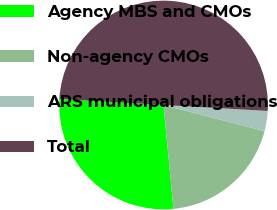Convert chart. <chart><loc_0><loc_0><loc_500><loc_500><pie_chart><fcel>Agency MBS and CMOs<fcel>Non-agency CMOs<fcel>ARS municipal obligations<fcel>Total<nl><fcel>27.43%<fcel>19.45%<fcel>3.12%<fcel>50.0%<nl></chart> 